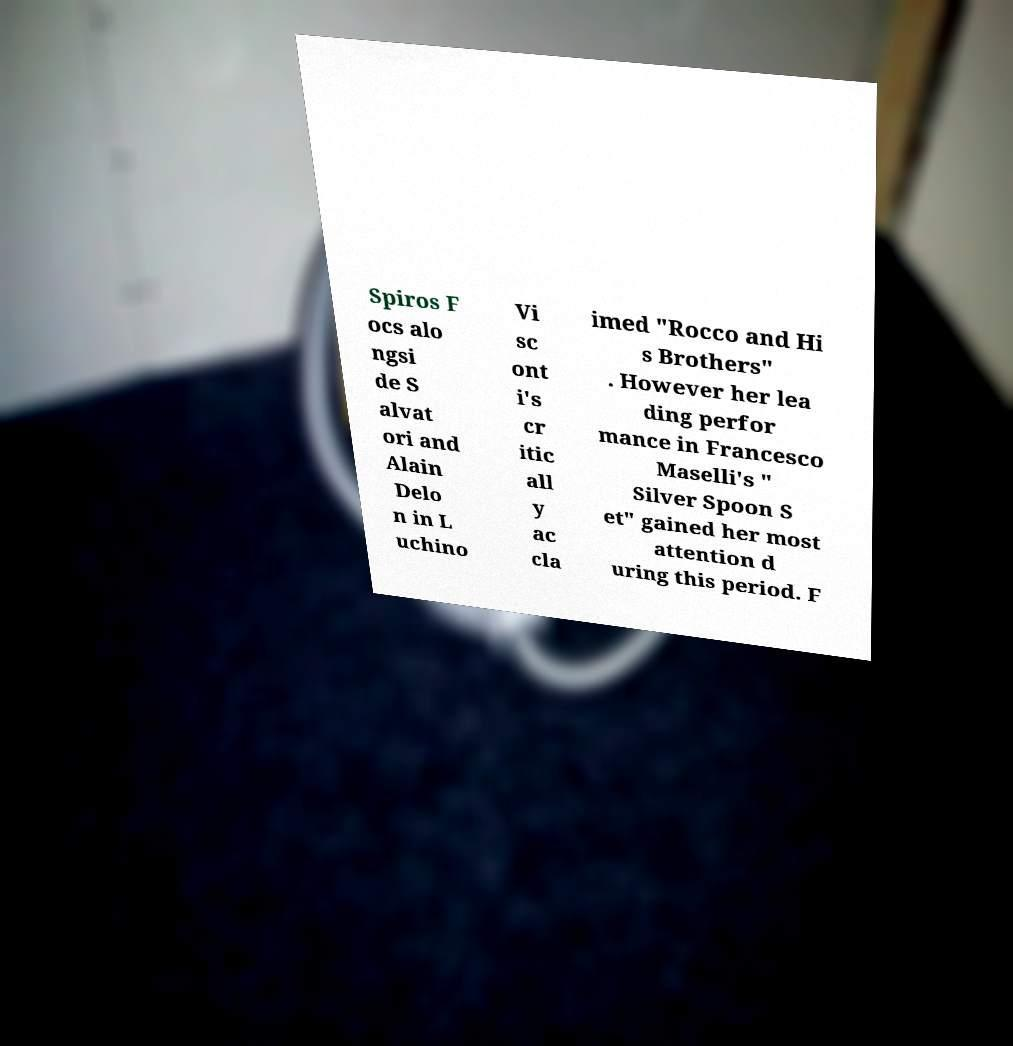What messages or text are displayed in this image? I need them in a readable, typed format. Spiros F ocs alo ngsi de S alvat ori and Alain Delo n in L uchino Vi sc ont i's cr itic all y ac cla imed "Rocco and Hi s Brothers" . However her lea ding perfor mance in Francesco Maselli's " Silver Spoon S et" gained her most attention d uring this period. F 